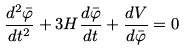Convert formula to latex. <formula><loc_0><loc_0><loc_500><loc_500>\frac { d ^ { 2 } \bar { \varphi } } { d t ^ { 2 } } + 3 H \frac { d \bar { \varphi } } { d t } + \frac { d V } { d \bar { \varphi } } = 0</formula> 